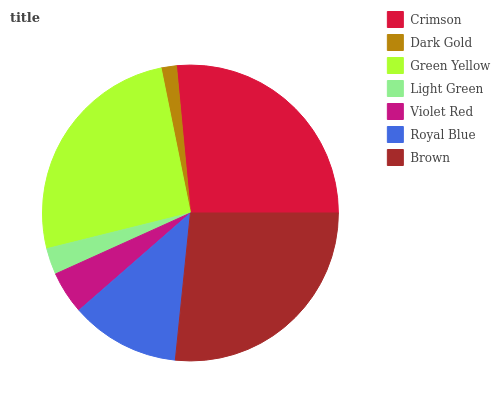Is Dark Gold the minimum?
Answer yes or no. Yes. Is Brown the maximum?
Answer yes or no. Yes. Is Green Yellow the minimum?
Answer yes or no. No. Is Green Yellow the maximum?
Answer yes or no. No. Is Green Yellow greater than Dark Gold?
Answer yes or no. Yes. Is Dark Gold less than Green Yellow?
Answer yes or no. Yes. Is Dark Gold greater than Green Yellow?
Answer yes or no. No. Is Green Yellow less than Dark Gold?
Answer yes or no. No. Is Royal Blue the high median?
Answer yes or no. Yes. Is Royal Blue the low median?
Answer yes or no. Yes. Is Light Green the high median?
Answer yes or no. No. Is Green Yellow the low median?
Answer yes or no. No. 